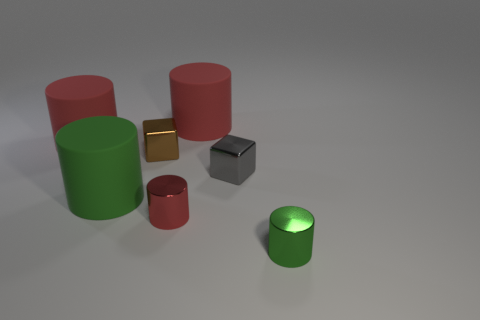Subtract all blue balls. How many red cylinders are left? 3 Subtract 1 cylinders. How many cylinders are left? 4 Subtract all red metal cylinders. How many cylinders are left? 4 Subtract all purple cylinders. Subtract all purple blocks. How many cylinders are left? 5 Add 3 big cyan rubber cylinders. How many objects exist? 10 Subtract all cylinders. How many objects are left? 2 Add 6 small brown metallic blocks. How many small brown metallic blocks are left? 7 Add 6 large purple rubber objects. How many large purple rubber objects exist? 6 Subtract 0 blue blocks. How many objects are left? 7 Subtract all large yellow rubber cubes. Subtract all small brown things. How many objects are left? 6 